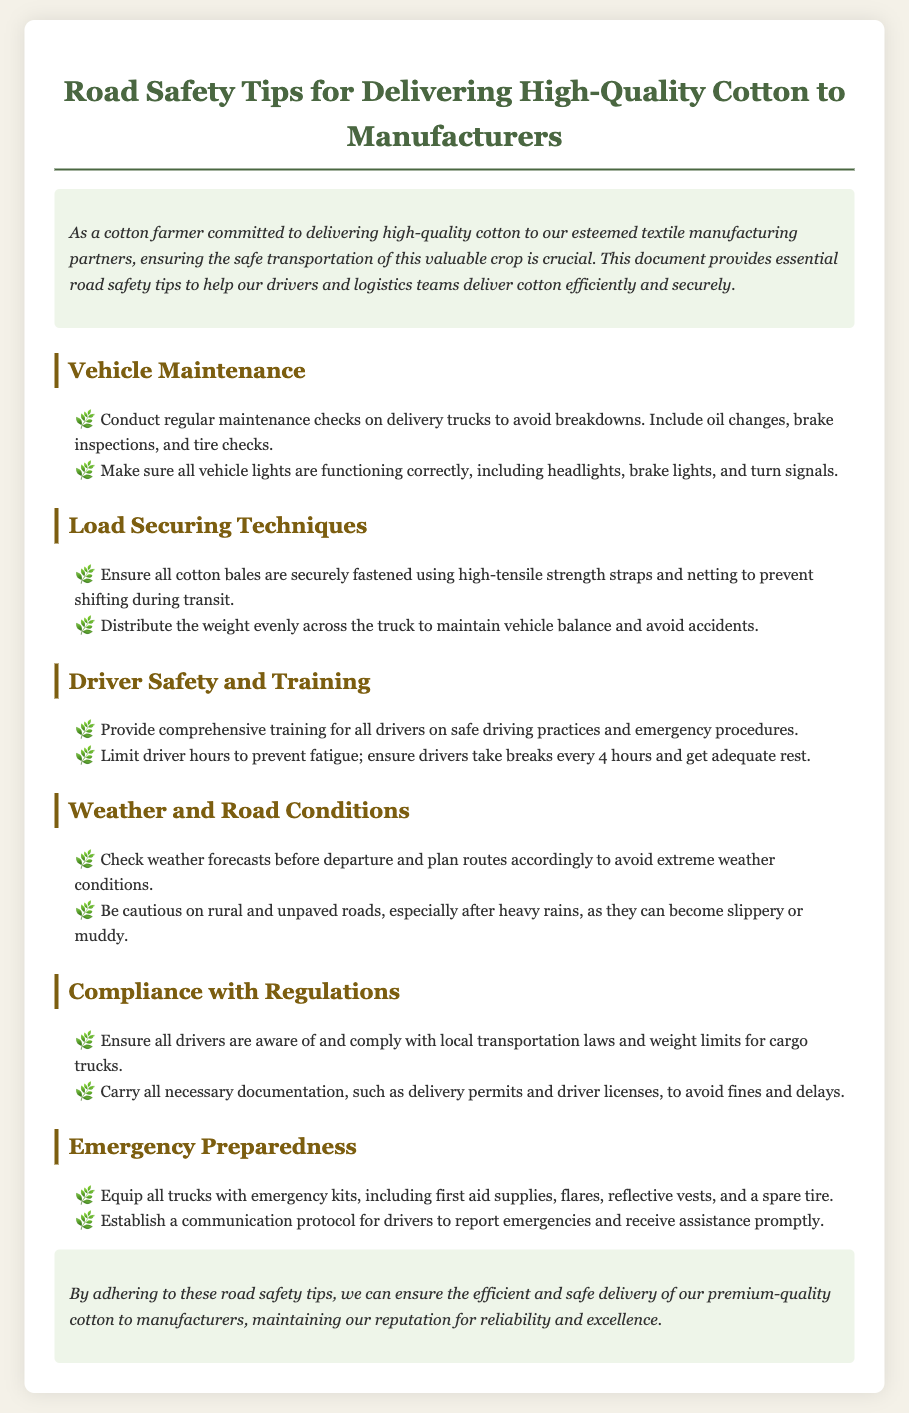what is the title of the document? The title of the document is stated in the header section, which summarizes the main topic addressed.
Answer: Road Safety Tips for Delivering High-Quality Cotton to Manufacturers what is one essential item to equip trucks with? The specific items that should be available in an emergency kit are mentioned in the document, under the emergency preparedness section.
Answer: emergency kits how often should drivers take breaks? The document specifies how often drivers should take breaks to prevent fatigue, which contributes to safe driving.
Answer: every 4 hours what should be checked before departure? The document mentions an important check that should be performed related to weather conditions before starting a journey.
Answer: weather forecasts what is a technique to secure cotton bales? The document provides a specific method for ensuring that cotton bales do not shift during transit, emphasizing safety and cargo integrity.
Answer: high-tensile strength straps how can weight affect vehicle safety? The document highlights the importance of weight distribution in relation to vehicle balance and the potential consequences of improper loading.
Answer: avoid accidents which section addresses vehicle maintenance? The document is divided into sections, and one specific section focuses on the necessary practices to ensure delivery trucks are in good working order.
Answer: Vehicle Maintenance what equipment should trucks have for emergencies? This question relates to details mentioned in a specific section about being prepared for emergencies during transportation.
Answer: first aid supplies how should cotton bales be loaded? The document outlines a practice that should be followed to properly load cotton bales for safe transportation.
Answer: securely fastened 